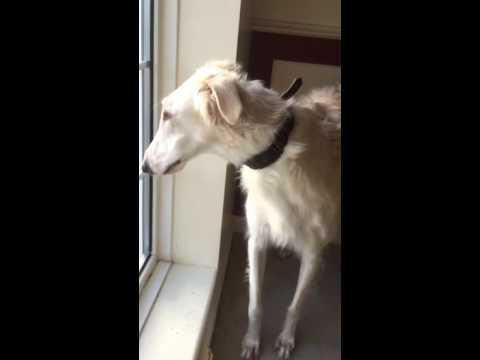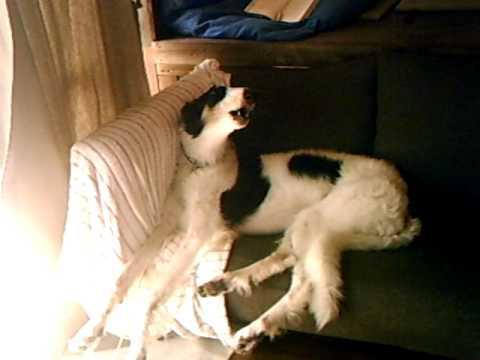The first image is the image on the left, the second image is the image on the right. Examine the images to the left and right. Is the description "One image shows at least one dog reclining on a dark sofa with its muzzle pointed upward and its mouth slightly opened." accurate? Answer yes or no. Yes. The first image is the image on the left, the second image is the image on the right. Considering the images on both sides, is "There is at least one Borzoi dog lying on a couch." valid? Answer yes or no. Yes. 